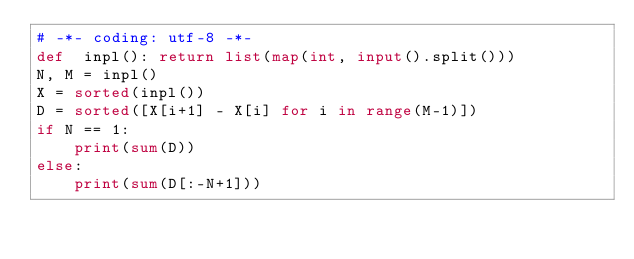Convert code to text. <code><loc_0><loc_0><loc_500><loc_500><_Python_># -*- coding: utf-8 -*-
def  inpl(): return list(map(int, input().split()))
N, M = inpl()
X = sorted(inpl())
D = sorted([X[i+1] - X[i] for i in range(M-1)])
if N == 1:
    print(sum(D))
else:
    print(sum(D[:-N+1]))</code> 